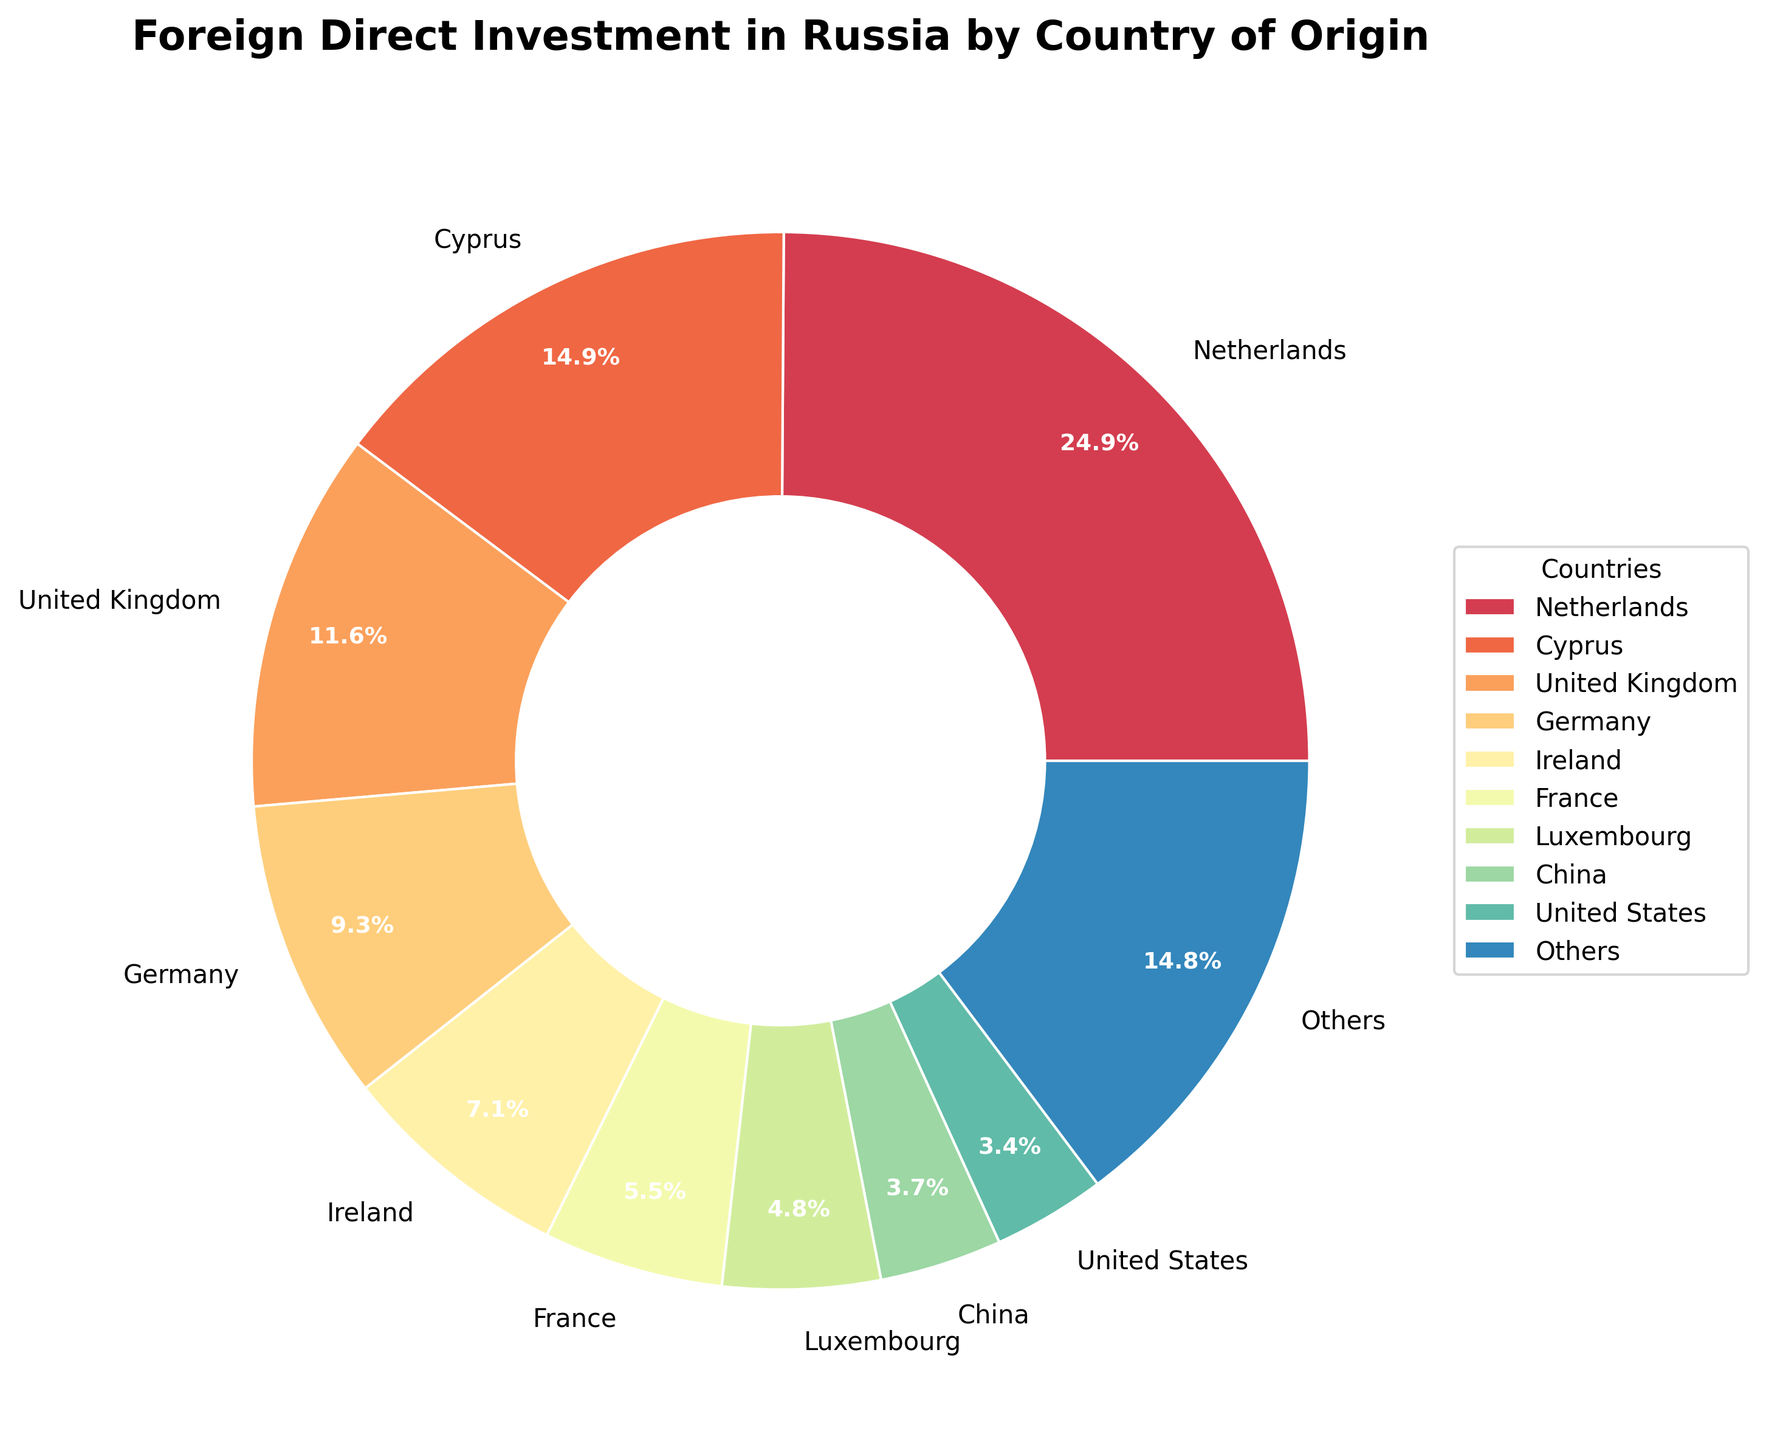Which country has the highest percentage of foreign direct investment in Russia? The sector of the pie chart showing the Netherlands is largest, with the label indicating 25.3%. This is the highest percentage among all countries.
Answer: The Netherlands How much larger is the Netherlands' investment compared to Cyprus' investment? The pie chart shows the Netherlands at 25.3% and Cyprus at 15.1%. Subtracting 15.1 from 25.3 gives 10.2%.
Answer: 10.2% Which countries contribute less than 3% individually to the foreign direct investment in Russia, and what is their combined contribution? According to the pie chart, 'Others' represent the countries contributing less than 3% individually. By summing the contributions from the United States, Switzerland, Sweden, Japan, South Korea, Italy, Finland, Austria, Turkey, United Arab Emirates, India, and Canada as shown in the pie chart, we get 19.4%.
Answer: 19.4% Is China contributing more or less than 5% to the foreign direct investment in Russia? The pie chart shows that China contributes 3.8%, which is less than 5%.
Answer: Less Combine Germany and France's contributions. Is their total contribution higher than that of the United Kingdom? Germany contributes 9.4% and France contributes 5.6%, which totals 15%. The United Kingdom's contribution is 11.8%. Therefore, the combined contribution of Germany and France is higher.
Answer: Higher What is the total percentage contribution of the top five investing countries in Russia? The top five countries according to the pie chart are the Netherlands (25.3%), Cyprus (15.1%), United Kingdom (11.8%), Germany (9.4%), and Ireland (7.2%). Adding these gives a total of 68.8%.
Answer: 68.8% How does the contribution from the United States compare visually with that from Germany in terms of pie chart slices? The United States' slice is visibly smaller than Germany's slice. The United States contributes 3.5%, whereas Germany contributes 9.4%.
Answer: Smaller If you combined the investments from Luxembourg and Ireland, would the total be greater than that from Germany? Luxembourg contributes 4.9% and Ireland contributes 7.2%, summing to 12.1%. This is greater than Germany's 9.4%.
Answer: Yes Which country has the smallest investment in Russia among those that are listed individually, excluding 'Others'? The country with the smallest individually listed investment is Canada at 0.5%.
Answer: Canada 